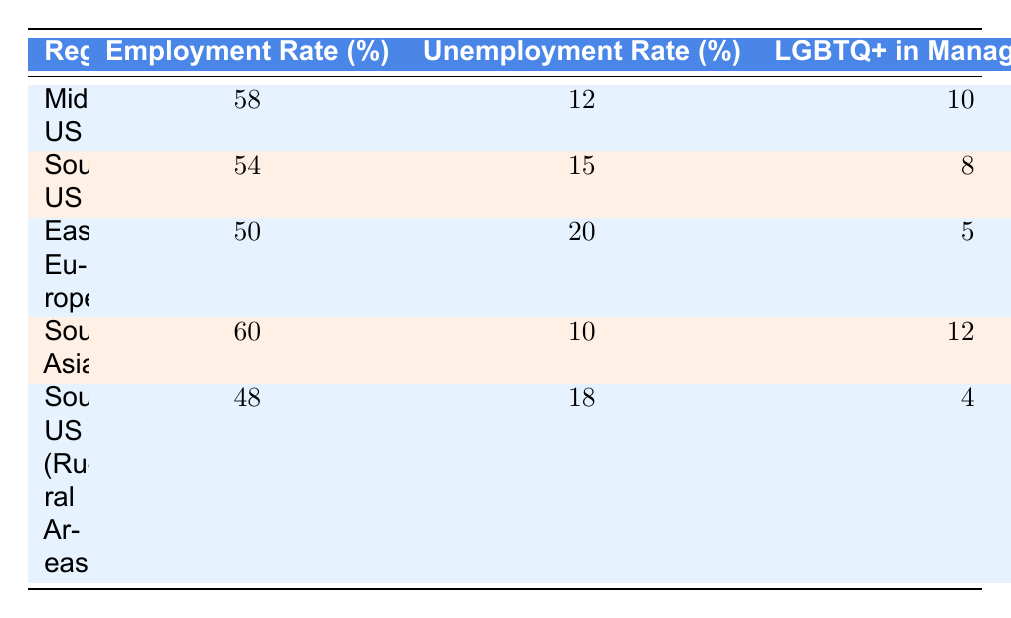What is the employment rate in the Southern US? The table indicates the employment rate under the Southern US row, which lists it as 54%.
Answer: 54 Which region has the highest average income? Comparing the average income values, the Midwestern US has the highest at 45000, while the others range from 30000 to 42000.
Answer: Midwestern US What is the unemployment rate in Eastern Europe, and how does it compare to the Southeastern Asia region? The unemployment rate in Eastern Europe is 20%, while Southeastern Asia has 10%. Comparing these two, 20% is higher than 10%.
Answer: 20%, higher How many LGBTQ+ individuals in management positions are there in the Southern US (Rural Areas)? The table specifies that there are 4% of LGBTQ+ individuals in management positions in the Southern US (Rural Areas).
Answer: 4 What is the average income difference between the Midwestern US and the Southern US? The average income in the Midwestern US is 45000, and in the Southern US, it's 42000. The difference is 45000 - 42000 = 3000.
Answer: 3000 Is the number of discrimination incidents highest in Eastern Europe? The table lists 40 discrimination incidents in Eastern Europe, which is higher than all other regions.
Answer: Yes Which region has the lowest employment rate, and what is that rate? The Southern US (Rural Areas) has the lowest employment rate of 48%. This can be found by comparing all employment rates in the table.
Answer: Southern US (Rural Areas), 48 What is the average percentage of LGBTQ+ individuals in management positions across all regions? To find the average, sum the management percentages (10 + 8 + 5 + 12 + 4 = 39) and divide by the number of regions (5). The average is 39/5 = 7.8%.
Answer: 7.8% 